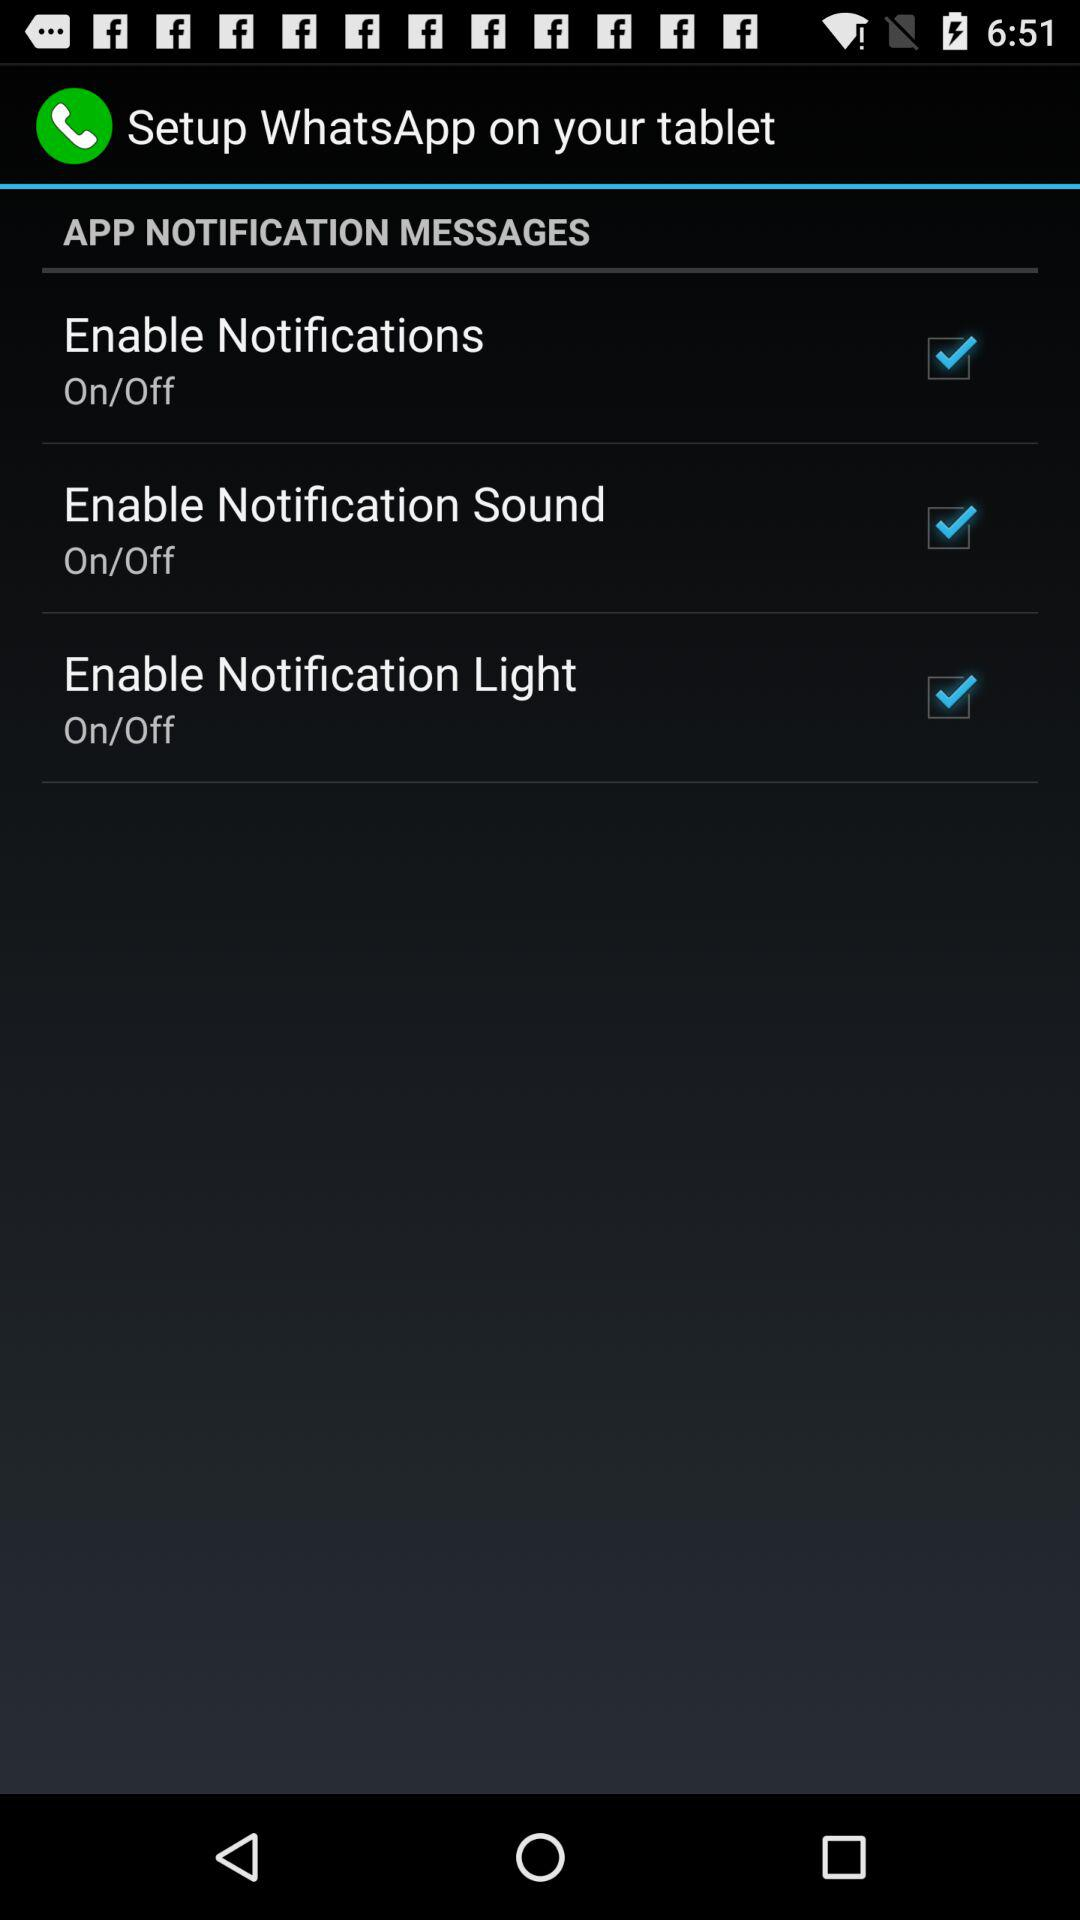What status does the enable notification light have? The status is on. 